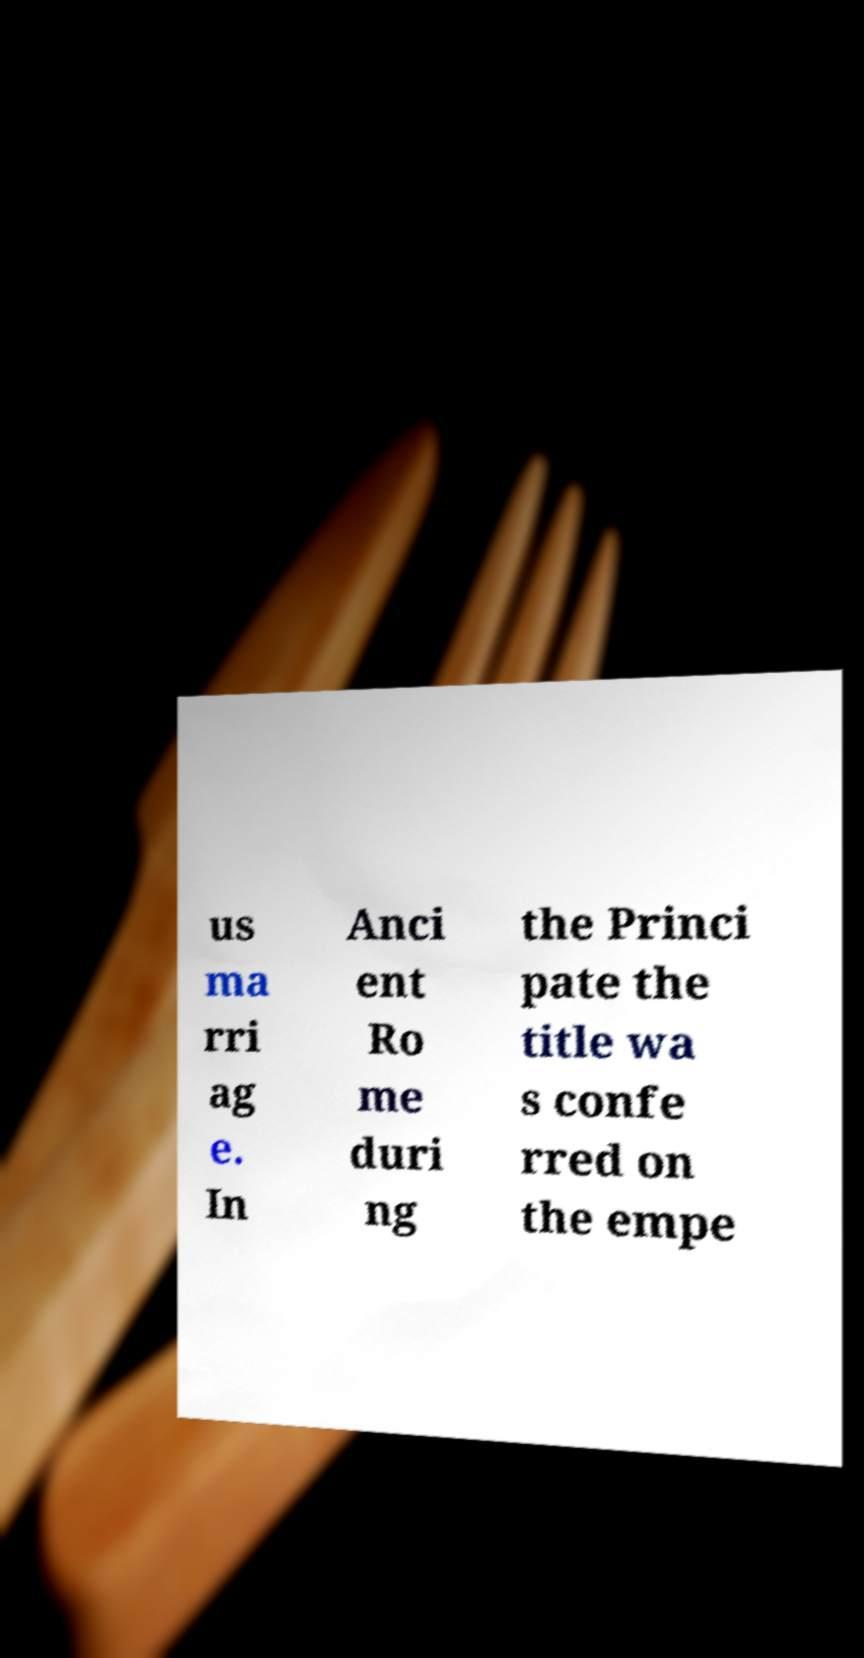Please read and relay the text visible in this image. What does it say? us ma rri ag e. In Anci ent Ro me duri ng the Princi pate the title wa s confe rred on the empe 